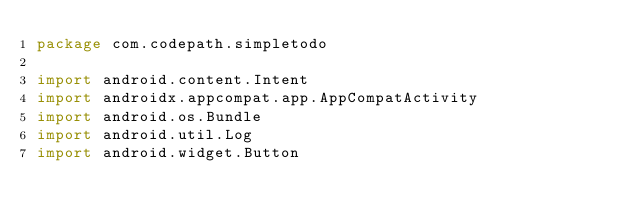<code> <loc_0><loc_0><loc_500><loc_500><_Kotlin_>package com.codepath.simpletodo

import android.content.Intent
import androidx.appcompat.app.AppCompatActivity
import android.os.Bundle
import android.util.Log
import android.widget.Button</code> 